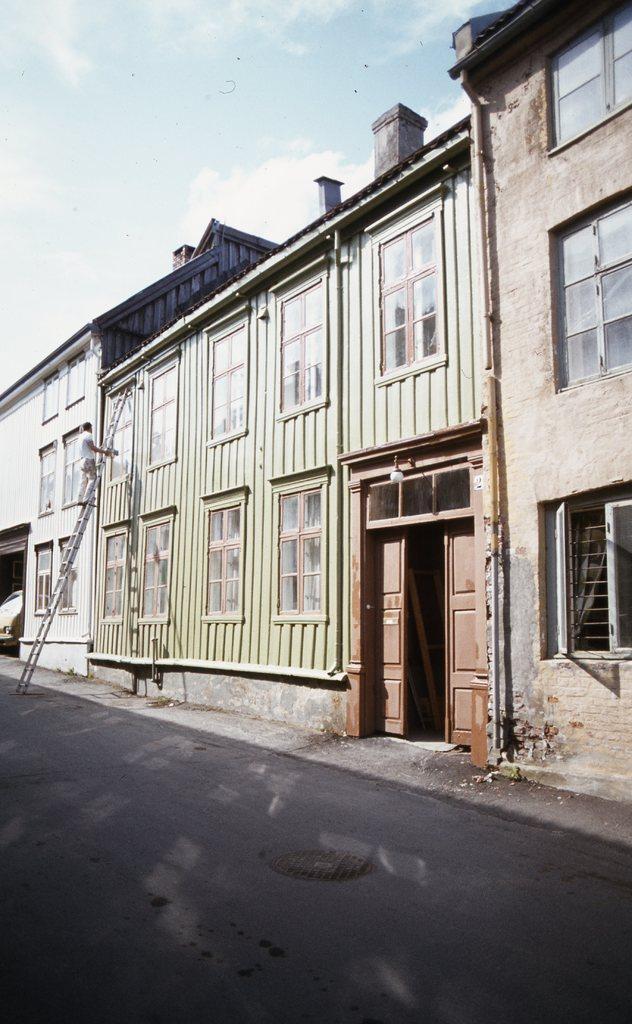Can you describe this image briefly? In this image, there are a few buildings with windows. We can see the ground and the sky with clouds. We can see a person standing on the ladder. We can also see an object on the left. 